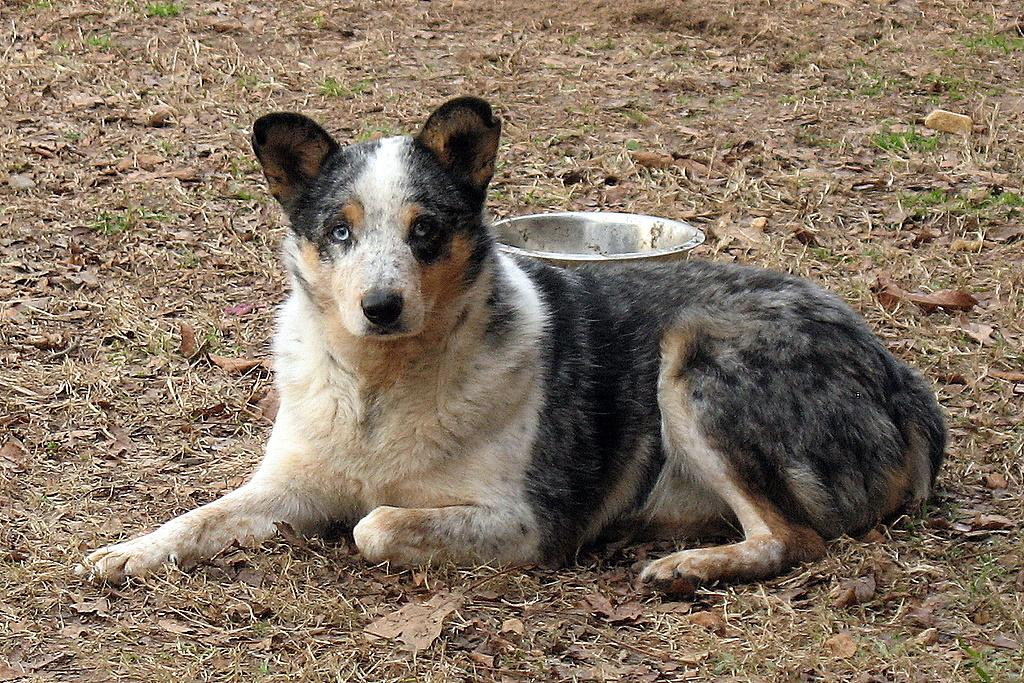What type of animal is in the image? There is a dog in the image. What is the dog doing in the image? The dog is sitting on the ground. What colors can be seen on the dog? The dog is white and black in color. What else can be seen in the image besides the dog? There is a container visible in the image. What type of jail can be seen in the image? There is no jail present in the image; it features a dog sitting on the ground and a container. What type of jeans is the dog wearing in the image? Dogs do not wear jeans, and there is no clothing visible on the dog in the image. 